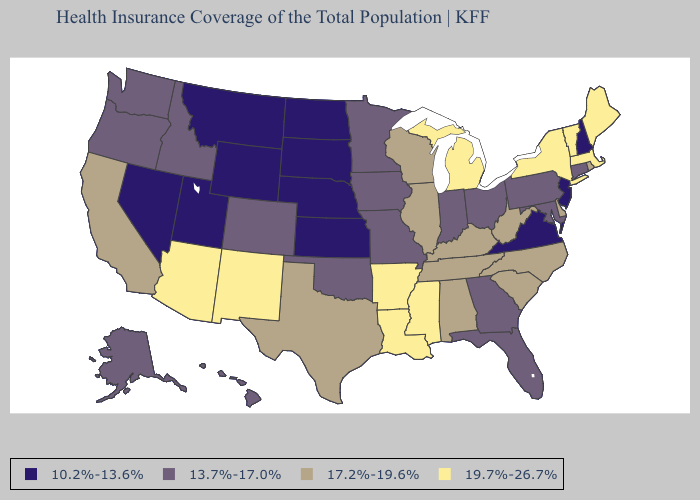Name the states that have a value in the range 19.7%-26.7%?
Answer briefly. Arizona, Arkansas, Louisiana, Maine, Massachusetts, Michigan, Mississippi, New Mexico, New York, Vermont. Among the states that border Montana , does Idaho have the lowest value?
Keep it brief. No. Is the legend a continuous bar?
Quick response, please. No. Among the states that border Wisconsin , does Illinois have the lowest value?
Concise answer only. No. What is the highest value in the West ?
Quick response, please. 19.7%-26.7%. Name the states that have a value in the range 19.7%-26.7%?
Keep it brief. Arizona, Arkansas, Louisiana, Maine, Massachusetts, Michigan, Mississippi, New Mexico, New York, Vermont. Does the map have missing data?
Keep it brief. No. Among the states that border Vermont , which have the highest value?
Answer briefly. Massachusetts, New York. Does Arizona have the lowest value in the USA?
Concise answer only. No. Name the states that have a value in the range 17.2%-19.6%?
Answer briefly. Alabama, California, Delaware, Illinois, Kentucky, North Carolina, Rhode Island, South Carolina, Tennessee, Texas, West Virginia, Wisconsin. What is the highest value in the MidWest ?
Short answer required. 19.7%-26.7%. Does California have a lower value than Idaho?
Write a very short answer. No. Which states have the highest value in the USA?
Short answer required. Arizona, Arkansas, Louisiana, Maine, Massachusetts, Michigan, Mississippi, New Mexico, New York, Vermont. Among the states that border Minnesota , which have the lowest value?
Keep it brief. North Dakota, South Dakota. Which states have the highest value in the USA?
Concise answer only. Arizona, Arkansas, Louisiana, Maine, Massachusetts, Michigan, Mississippi, New Mexico, New York, Vermont. 